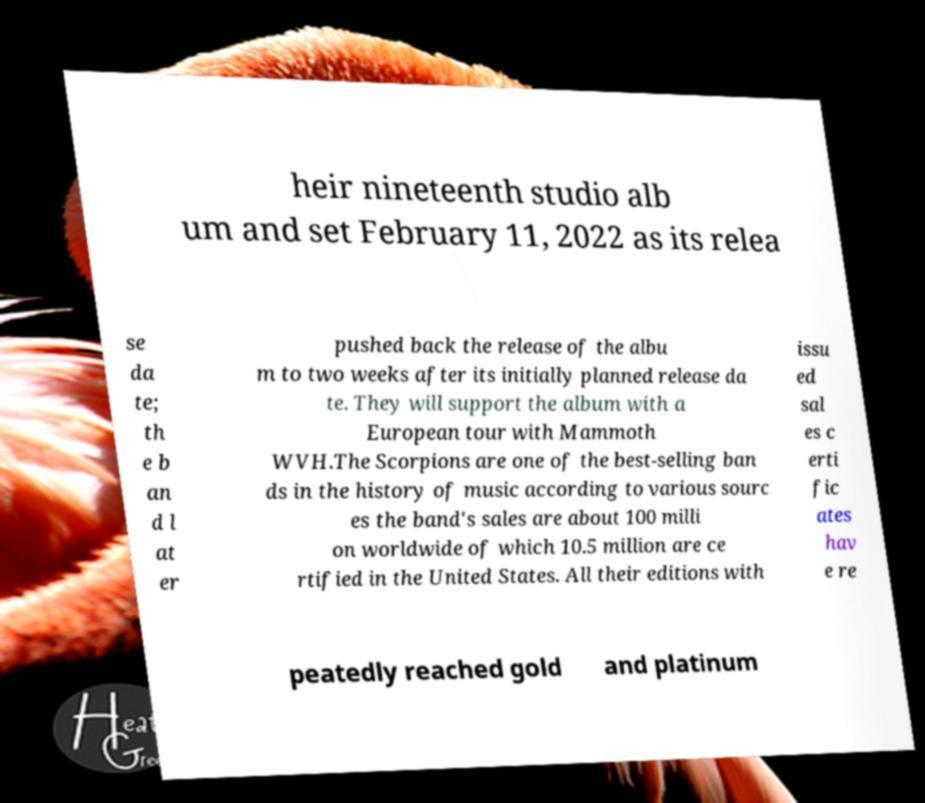Please read and relay the text visible in this image. What does it say? heir nineteenth studio alb um and set February 11, 2022 as its relea se da te; th e b an d l at er pushed back the release of the albu m to two weeks after its initially planned release da te. They will support the album with a European tour with Mammoth WVH.The Scorpions are one of the best-selling ban ds in the history of music according to various sourc es the band's sales are about 100 milli on worldwide of which 10.5 million are ce rtified in the United States. All their editions with issu ed sal es c erti fic ates hav e re peatedly reached gold and platinum 